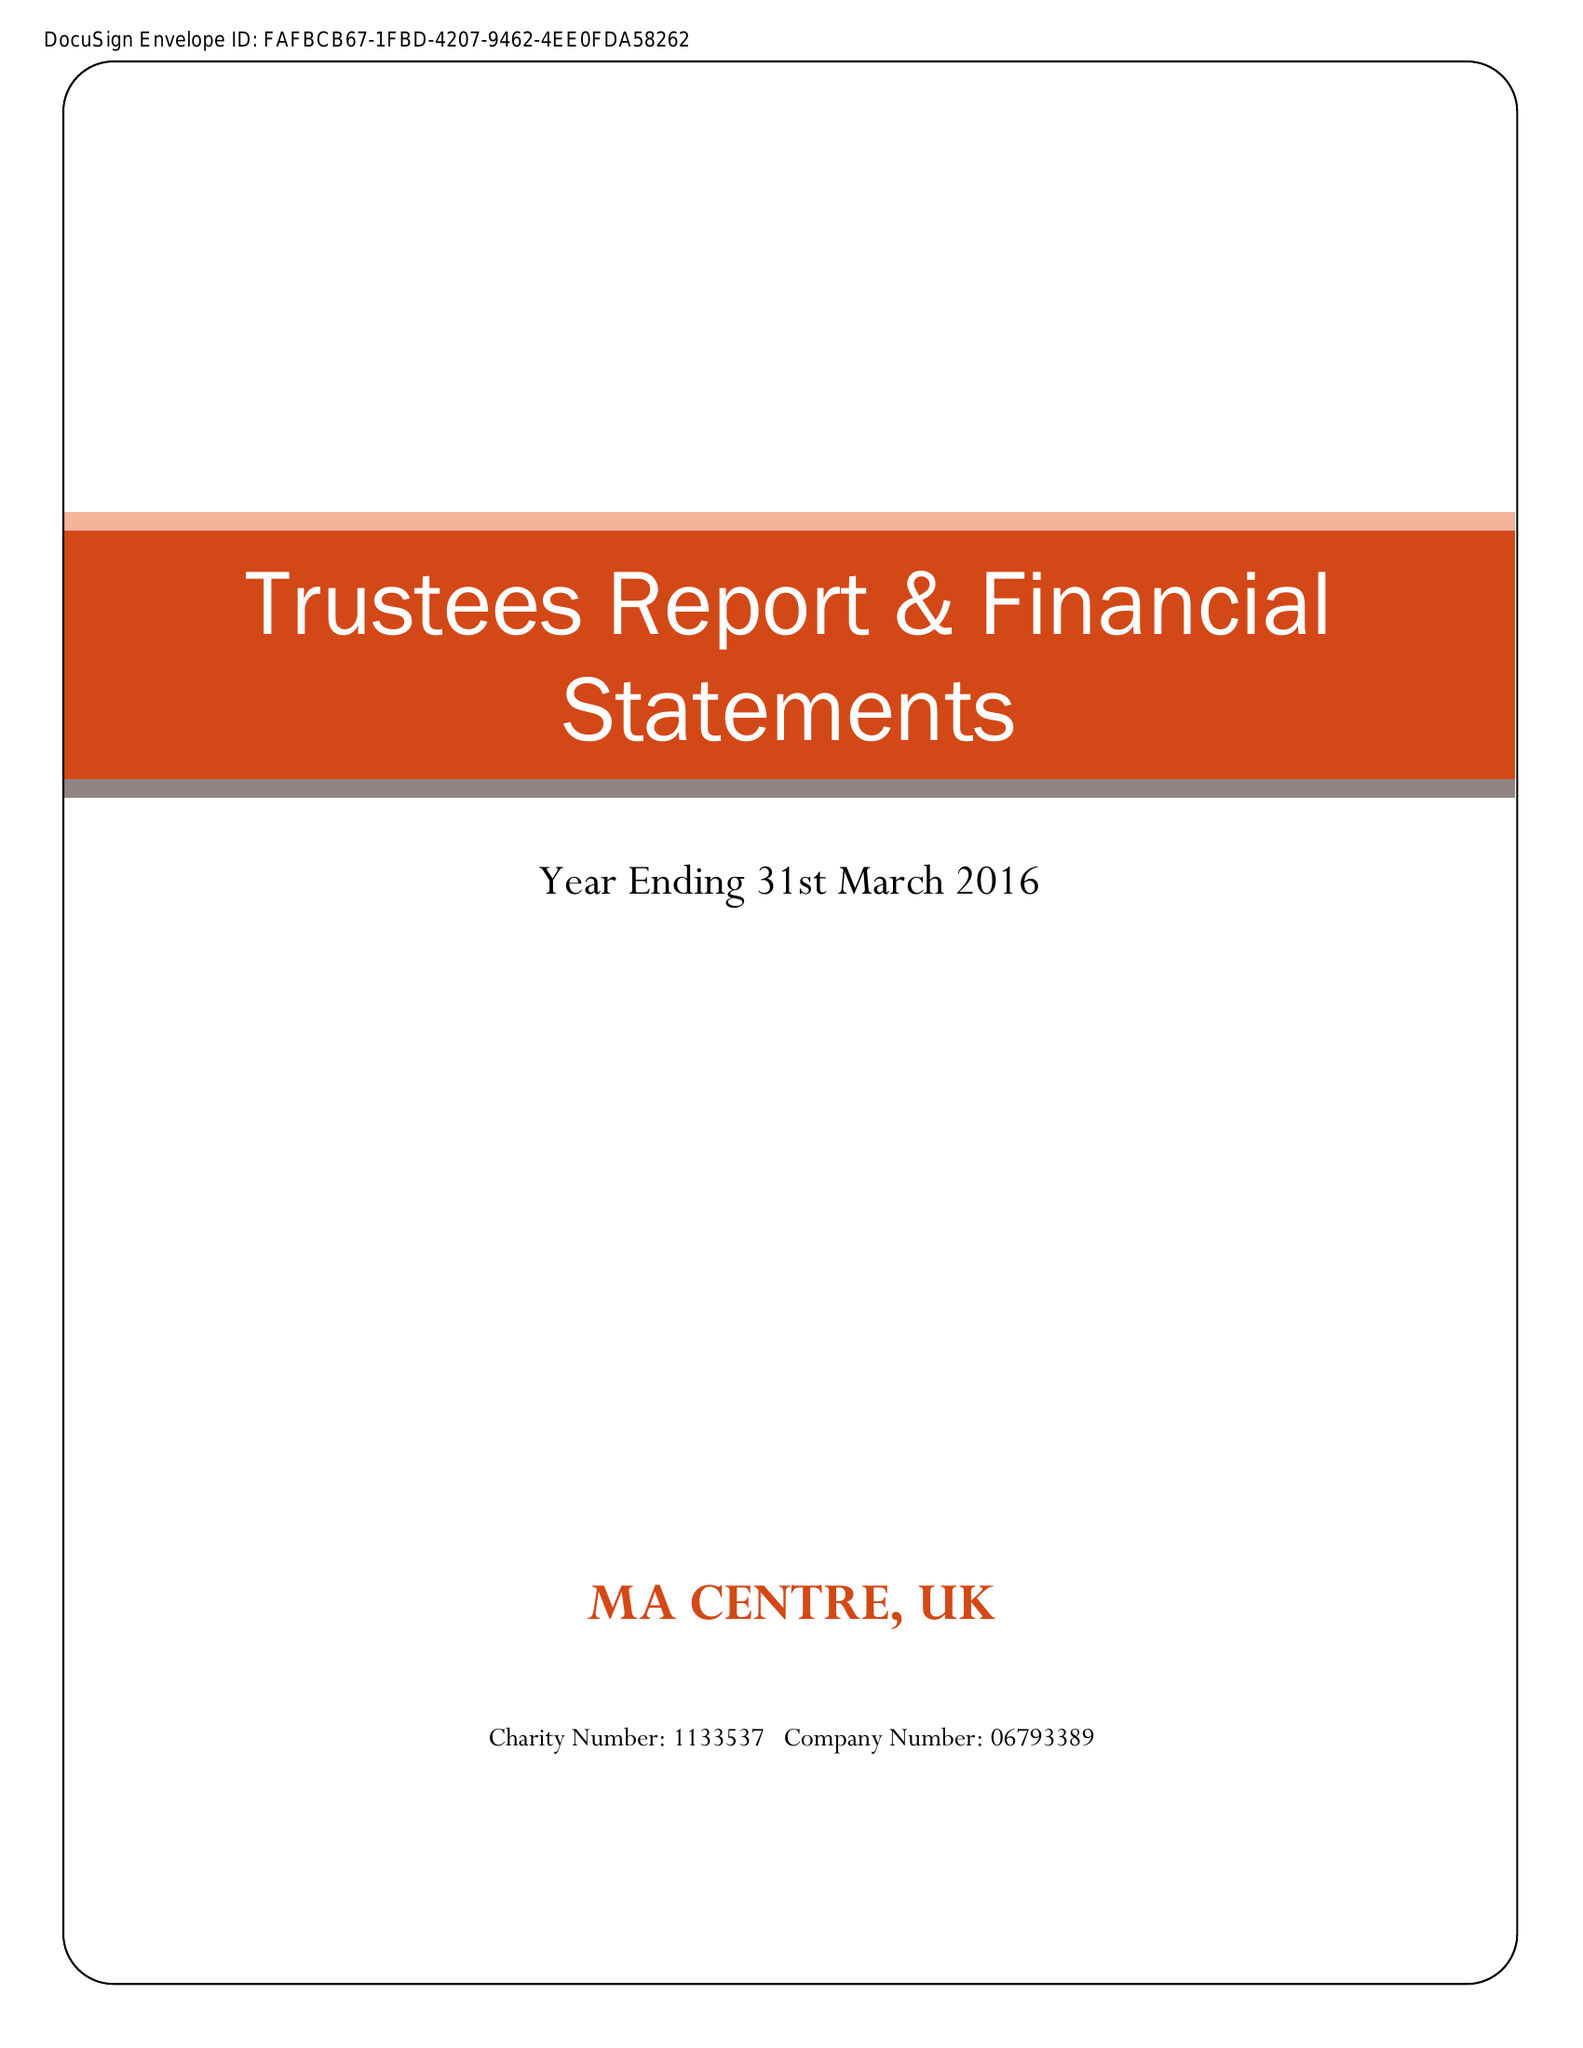What is the value for the charity_name?
Answer the question using a single word or phrase. Ma Centre Uk 